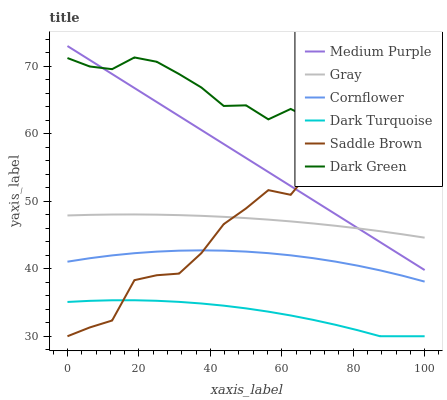Does Dark Turquoise have the minimum area under the curve?
Answer yes or no. Yes. Does Dark Green have the maximum area under the curve?
Answer yes or no. Yes. Does Cornflower have the minimum area under the curve?
Answer yes or no. No. Does Cornflower have the maximum area under the curve?
Answer yes or no. No. Is Medium Purple the smoothest?
Answer yes or no. Yes. Is Saddle Brown the roughest?
Answer yes or no. Yes. Is Cornflower the smoothest?
Answer yes or no. No. Is Cornflower the roughest?
Answer yes or no. No. Does Dark Turquoise have the lowest value?
Answer yes or no. Yes. Does Cornflower have the lowest value?
Answer yes or no. No. Does Medium Purple have the highest value?
Answer yes or no. Yes. Does Cornflower have the highest value?
Answer yes or no. No. Is Cornflower less than Gray?
Answer yes or no. Yes. Is Gray greater than Dark Turquoise?
Answer yes or no. Yes. Does Saddle Brown intersect Dark Turquoise?
Answer yes or no. Yes. Is Saddle Brown less than Dark Turquoise?
Answer yes or no. No. Is Saddle Brown greater than Dark Turquoise?
Answer yes or no. No. Does Cornflower intersect Gray?
Answer yes or no. No. 